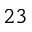Convert formula to latex. <formula><loc_0><loc_0><loc_500><loc_500>^ { 2 3 }</formula> 